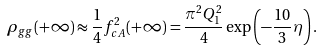Convert formula to latex. <formula><loc_0><loc_0><loc_500><loc_500>\rho _ { g g } ( + \infty ) \approx \frac { 1 } { 4 } f _ { c A } ^ { 2 } ( + \infty ) = \frac { \pi ^ { 2 } Q _ { 1 } ^ { 2 } } { 4 } \exp \left ( - \frac { 1 0 } { 3 } \eta \right ) .</formula> 